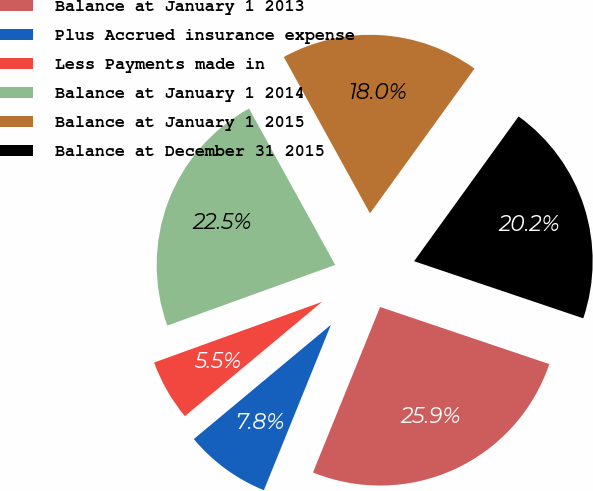Convert chart to OTSL. <chart><loc_0><loc_0><loc_500><loc_500><pie_chart><fcel>Balance at January 1 2013<fcel>Plus Accrued insurance expense<fcel>Less Payments made in<fcel>Balance at January 1 2014<fcel>Balance at January 1 2015<fcel>Balance at December 31 2015<nl><fcel>25.95%<fcel>7.81%<fcel>5.54%<fcel>22.5%<fcel>17.97%<fcel>20.23%<nl></chart> 